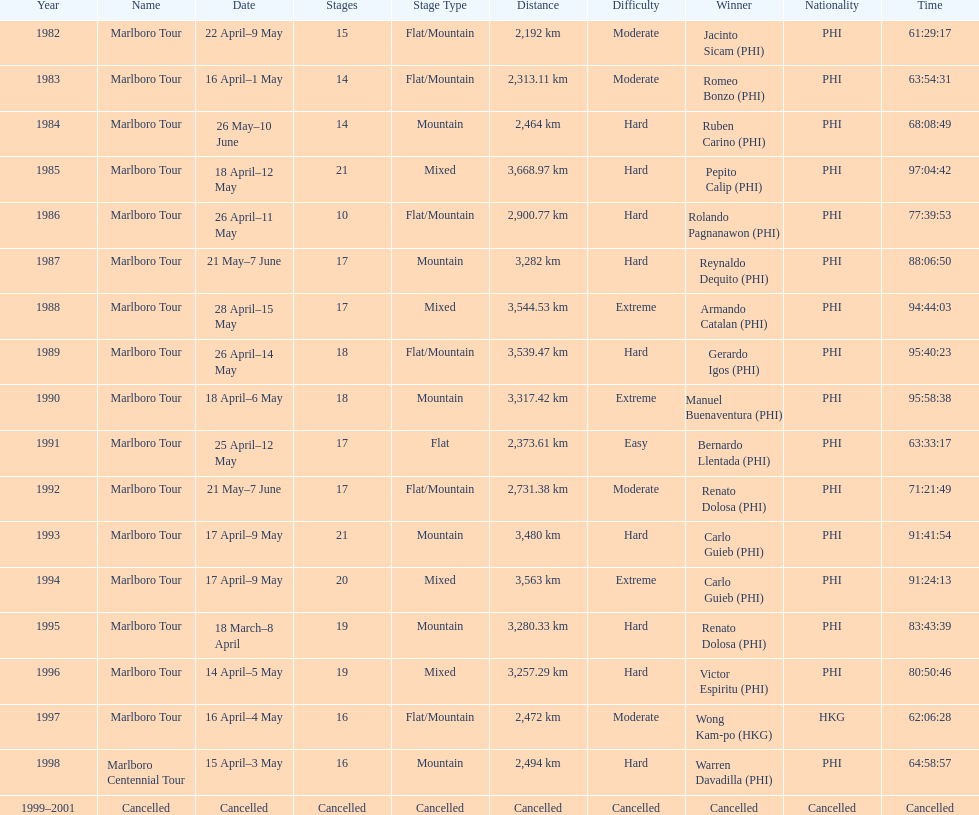How many stages was the 1982 marlboro tour? 15. 